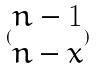Convert formula to latex. <formula><loc_0><loc_0><loc_500><loc_500>( \begin{matrix} n - 1 \\ n - x \end{matrix} )</formula> 